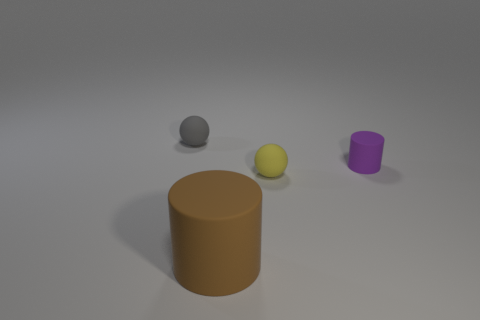Add 1 big red cylinders. How many objects exist? 5 Add 3 tiny rubber balls. How many tiny rubber balls exist? 5 Subtract 0 yellow blocks. How many objects are left? 4 Subtract all big green things. Subtract all brown rubber things. How many objects are left? 3 Add 1 tiny objects. How many tiny objects are left? 4 